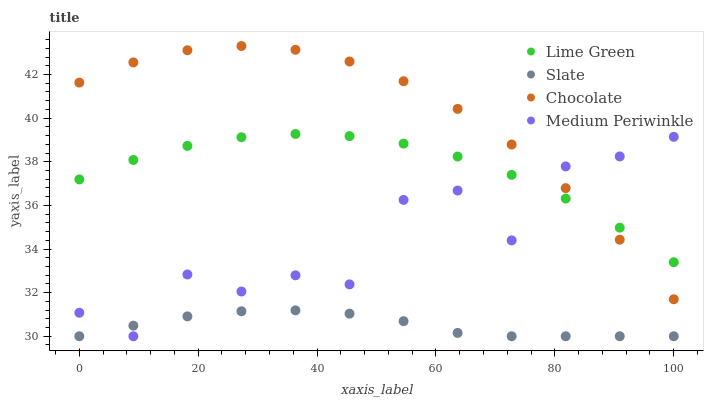Does Slate have the minimum area under the curve?
Answer yes or no. Yes. Does Chocolate have the maximum area under the curve?
Answer yes or no. Yes. Does Lime Green have the minimum area under the curve?
Answer yes or no. No. Does Lime Green have the maximum area under the curve?
Answer yes or no. No. Is Slate the smoothest?
Answer yes or no. Yes. Is Medium Periwinkle the roughest?
Answer yes or no. Yes. Is Lime Green the smoothest?
Answer yes or no. No. Is Lime Green the roughest?
Answer yes or no. No. Does Medium Periwinkle have the lowest value?
Answer yes or no. Yes. Does Lime Green have the lowest value?
Answer yes or no. No. Does Chocolate have the highest value?
Answer yes or no. Yes. Does Lime Green have the highest value?
Answer yes or no. No. Is Slate less than Lime Green?
Answer yes or no. Yes. Is Chocolate greater than Slate?
Answer yes or no. Yes. Does Medium Periwinkle intersect Slate?
Answer yes or no. Yes. Is Medium Periwinkle less than Slate?
Answer yes or no. No. Is Medium Periwinkle greater than Slate?
Answer yes or no. No. Does Slate intersect Lime Green?
Answer yes or no. No. 